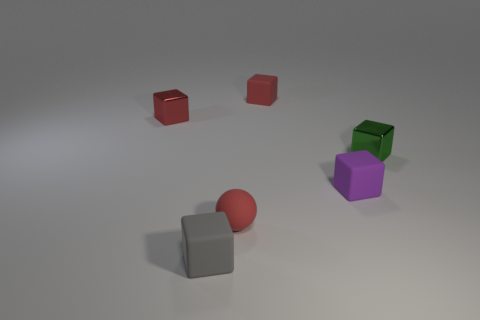What color is the small matte sphere?
Offer a terse response. Red. Are there more big cyan spheres than small gray objects?
Keep it short and to the point. No. How many objects are small gray blocks that are left of the purple thing or small red cubes?
Provide a succinct answer. 3. Does the tiny gray thing have the same material as the tiny green object?
Give a very brief answer. No. What is the size of the purple matte thing that is the same shape as the red shiny object?
Provide a succinct answer. Small. There is a metal thing left of the tiny purple object; does it have the same shape as the tiny red matte object behind the small red rubber sphere?
Your response must be concise. Yes. What number of other things are there of the same material as the green thing
Offer a very short reply. 1. Is there anything else that is the same shape as the gray matte thing?
Provide a succinct answer. Yes. There is a tiny matte block behind the shiny block that is in front of the tiny red metallic block left of the small gray matte cube; what color is it?
Your answer should be very brief. Red. There is a matte thing that is both behind the gray rubber thing and on the left side of the tiny red rubber block; what shape is it?
Offer a very short reply. Sphere. 